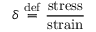Convert formula to latex. <formula><loc_0><loc_0><loc_500><loc_500>\delta \ { \stackrel { d e f } { = } } \ { \frac { s t r e s s } { s t r a i n } }</formula> 